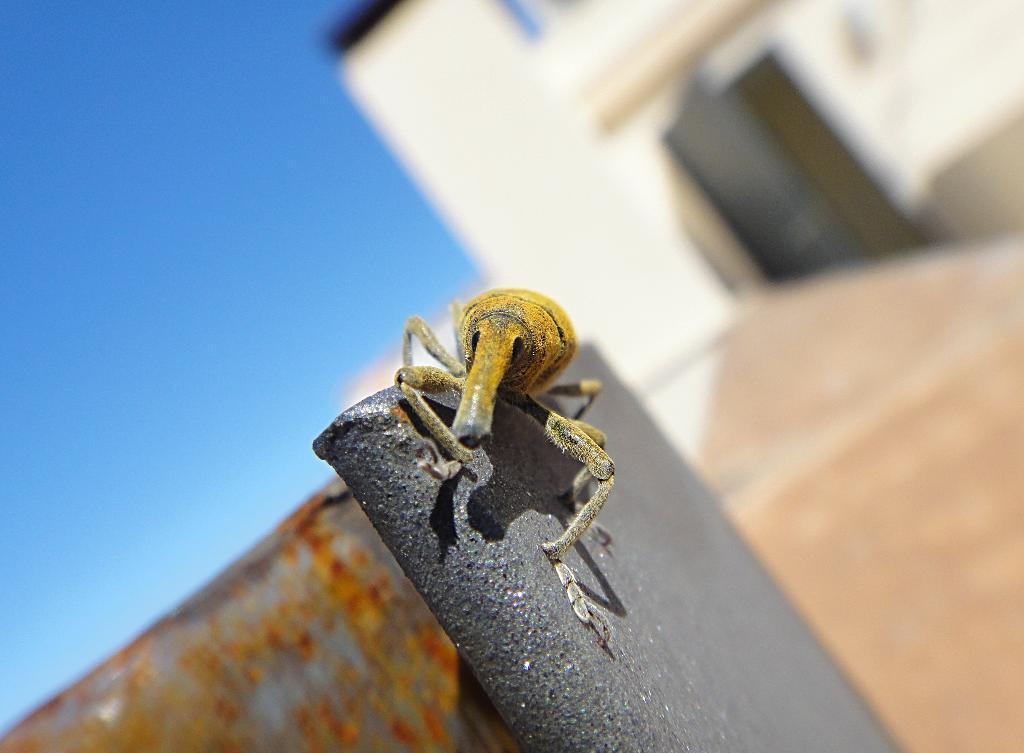Please provide a concise description of this image. In the picture I can see an insect which is on wall and in the background of the picture there is house. 